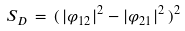Convert formula to latex. <formula><loc_0><loc_0><loc_500><loc_500>S _ { D } \, = \, ( \, | \varphi _ { 1 2 } | ^ { 2 } - | \varphi _ { 2 1 } | ^ { 2 } \, ) ^ { 2 }</formula> 